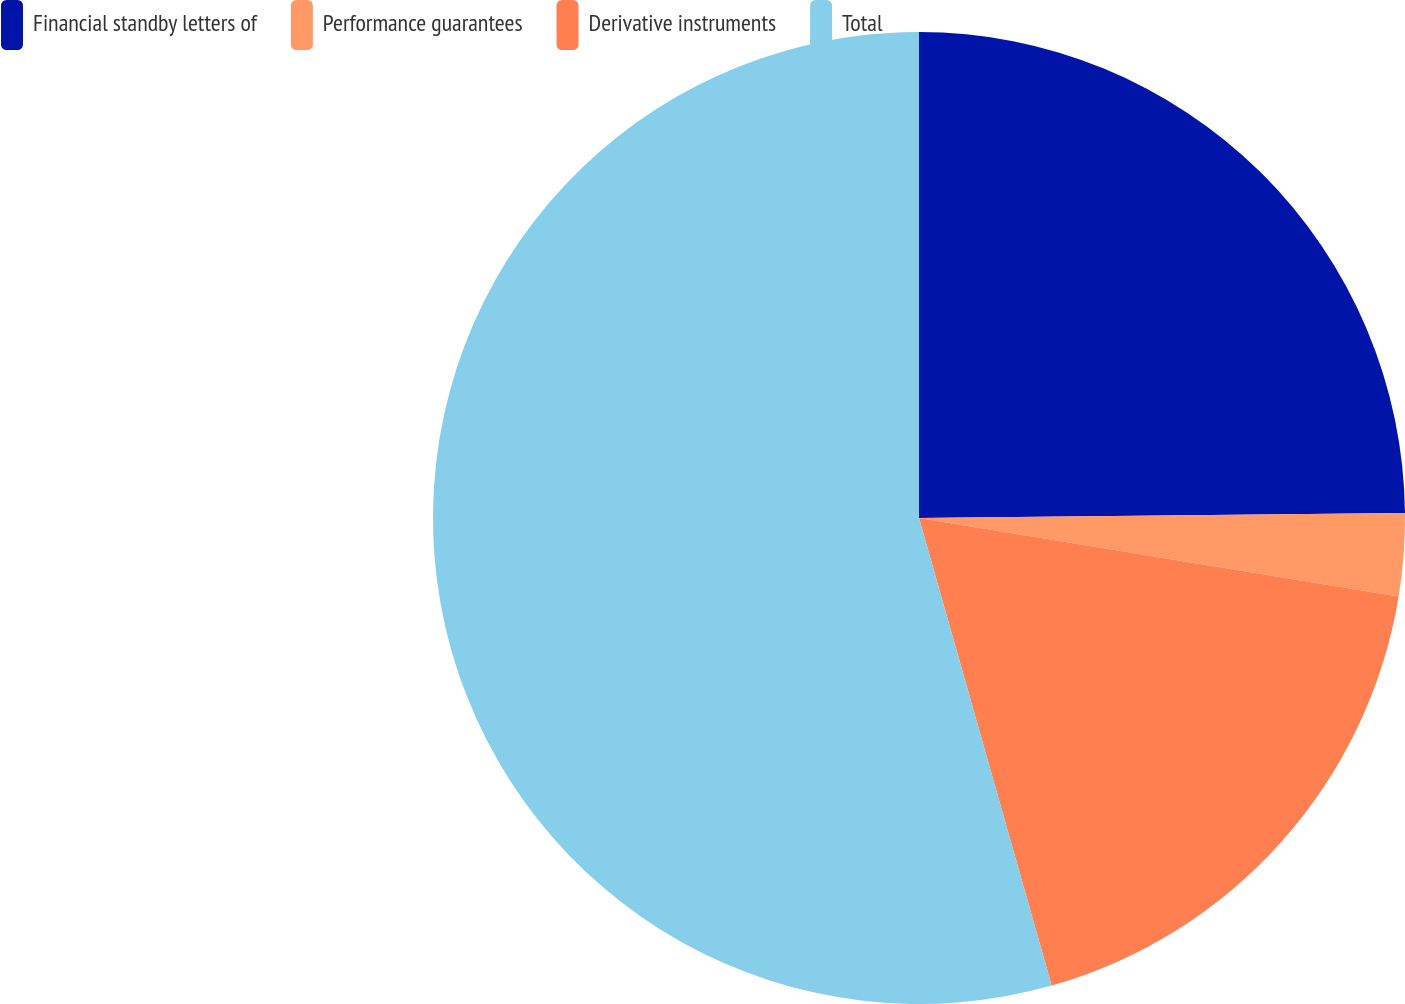Convert chart to OTSL. <chart><loc_0><loc_0><loc_500><loc_500><pie_chart><fcel>Financial standby letters of<fcel>Performance guarantees<fcel>Derivative instruments<fcel>Total<nl><fcel>24.84%<fcel>2.74%<fcel>18.02%<fcel>54.4%<nl></chart> 